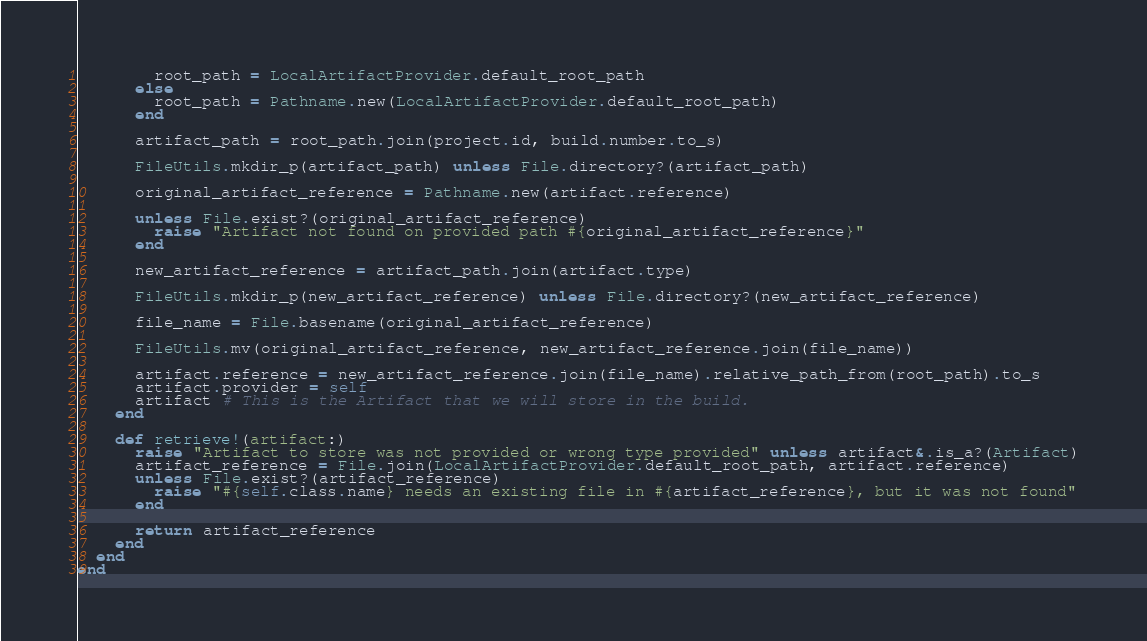<code> <loc_0><loc_0><loc_500><loc_500><_Ruby_>        root_path = LocalArtifactProvider.default_root_path
      else
        root_path = Pathname.new(LocalArtifactProvider.default_root_path)
      end

      artifact_path = root_path.join(project.id, build.number.to_s)

      FileUtils.mkdir_p(artifact_path) unless File.directory?(artifact_path)

      original_artifact_reference = Pathname.new(artifact.reference)

      unless File.exist?(original_artifact_reference)
        raise "Artifact not found on provided path #{original_artifact_reference}"
      end

      new_artifact_reference = artifact_path.join(artifact.type)

      FileUtils.mkdir_p(new_artifact_reference) unless File.directory?(new_artifact_reference)

      file_name = File.basename(original_artifact_reference)

      FileUtils.mv(original_artifact_reference, new_artifact_reference.join(file_name))

      artifact.reference = new_artifact_reference.join(file_name).relative_path_from(root_path).to_s
      artifact.provider = self
      artifact # This is the Artifact that we will store in the build.
    end

    def retrieve!(artifact:)
      raise "Artifact to store was not provided or wrong type provided" unless artifact&.is_a?(Artifact)
      artifact_reference = File.join(LocalArtifactProvider.default_root_path, artifact.reference)
      unless File.exist?(artifact_reference)
        raise "#{self.class.name} needs an existing file in #{artifact_reference}, but it was not found"
      end

      return artifact_reference
    end
  end
end
</code> 